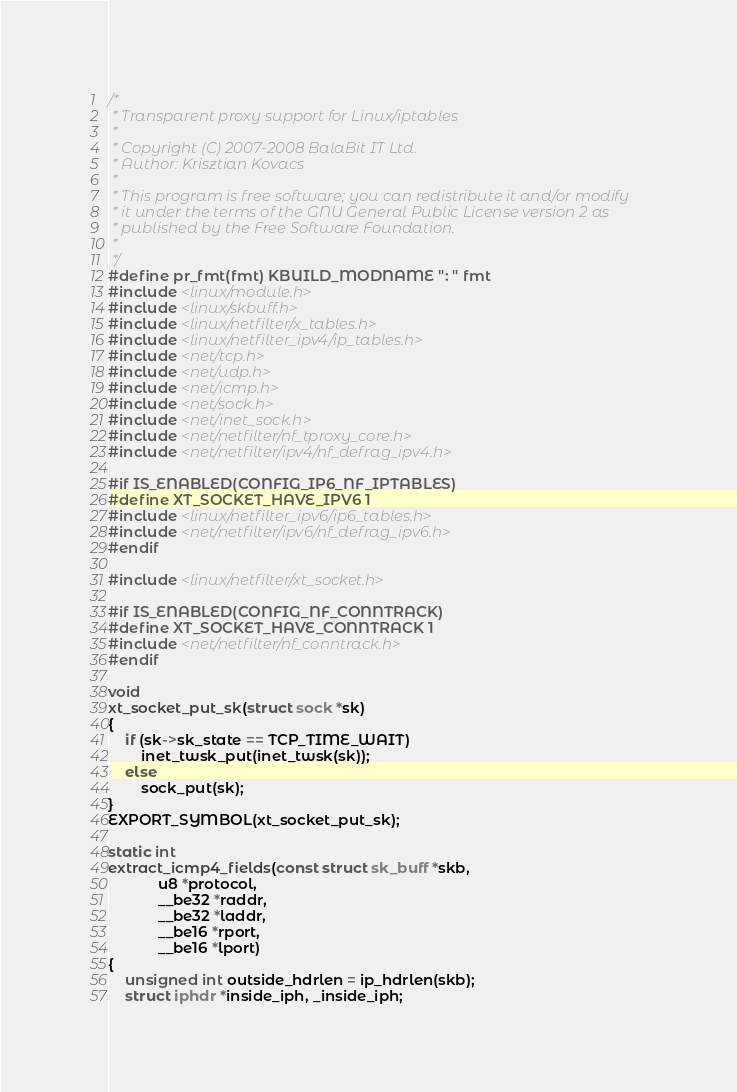Convert code to text. <code><loc_0><loc_0><loc_500><loc_500><_C_>/*
 * Transparent proxy support for Linux/iptables
 *
 * Copyright (C) 2007-2008 BalaBit IT Ltd.
 * Author: Krisztian Kovacs
 *
 * This program is free software; you can redistribute it and/or modify
 * it under the terms of the GNU General Public License version 2 as
 * published by the Free Software Foundation.
 *
 */
#define pr_fmt(fmt) KBUILD_MODNAME ": " fmt
#include <linux/module.h>
#include <linux/skbuff.h>
#include <linux/netfilter/x_tables.h>
#include <linux/netfilter_ipv4/ip_tables.h>
#include <net/tcp.h>
#include <net/udp.h>
#include <net/icmp.h>
#include <net/sock.h>
#include <net/inet_sock.h>
#include <net/netfilter/nf_tproxy_core.h>
#include <net/netfilter/ipv4/nf_defrag_ipv4.h>

#if IS_ENABLED(CONFIG_IP6_NF_IPTABLES)
#define XT_SOCKET_HAVE_IPV6 1
#include <linux/netfilter_ipv6/ip6_tables.h>
#include <net/netfilter/ipv6/nf_defrag_ipv6.h>
#endif

#include <linux/netfilter/xt_socket.h>

#if IS_ENABLED(CONFIG_NF_CONNTRACK)
#define XT_SOCKET_HAVE_CONNTRACK 1
#include <net/netfilter/nf_conntrack.h>
#endif

void
xt_socket_put_sk(struct sock *sk)
{
	if (sk->sk_state == TCP_TIME_WAIT)
		inet_twsk_put(inet_twsk(sk));
	else
		sock_put(sk);
}
EXPORT_SYMBOL(xt_socket_put_sk);

static int
extract_icmp4_fields(const struct sk_buff *skb,
		    u8 *protocol,
		    __be32 *raddr,
		    __be32 *laddr,
		    __be16 *rport,
		    __be16 *lport)
{
	unsigned int outside_hdrlen = ip_hdrlen(skb);
	struct iphdr *inside_iph, _inside_iph;</code> 